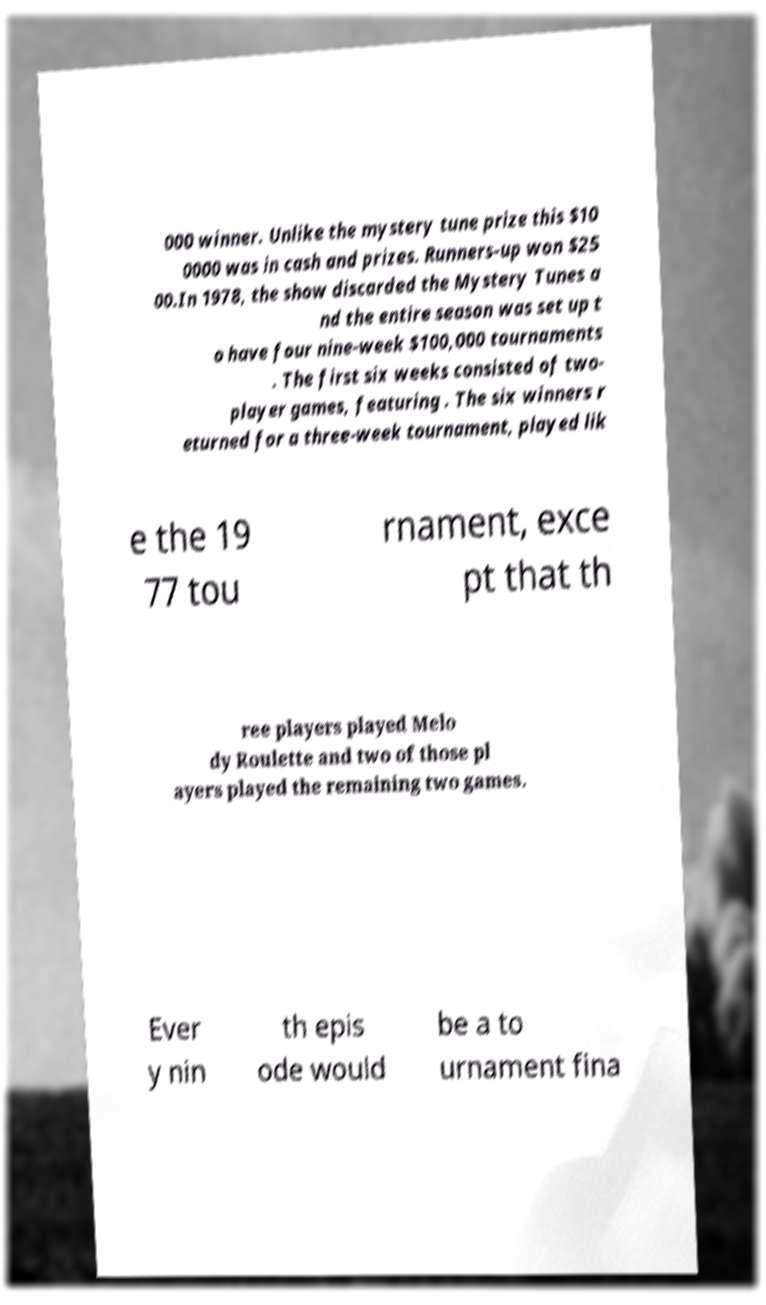There's text embedded in this image that I need extracted. Can you transcribe it verbatim? 000 winner. Unlike the mystery tune prize this $10 0000 was in cash and prizes. Runners-up won $25 00.In 1978, the show discarded the Mystery Tunes a nd the entire season was set up t o have four nine-week $100,000 tournaments . The first six weeks consisted of two- player games, featuring . The six winners r eturned for a three-week tournament, played lik e the 19 77 tou rnament, exce pt that th ree players played Melo dy Roulette and two of those pl ayers played the remaining two games. Ever y nin th epis ode would be a to urnament fina 